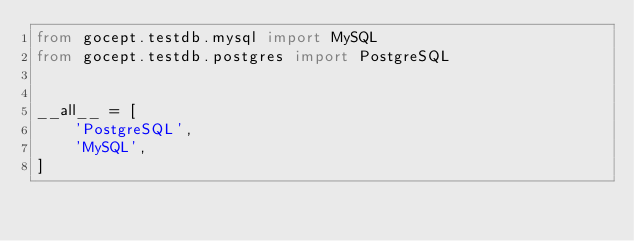<code> <loc_0><loc_0><loc_500><loc_500><_Python_>from gocept.testdb.mysql import MySQL
from gocept.testdb.postgres import PostgreSQL


__all__ = [
    'PostgreSQL',
    'MySQL',
]
</code> 